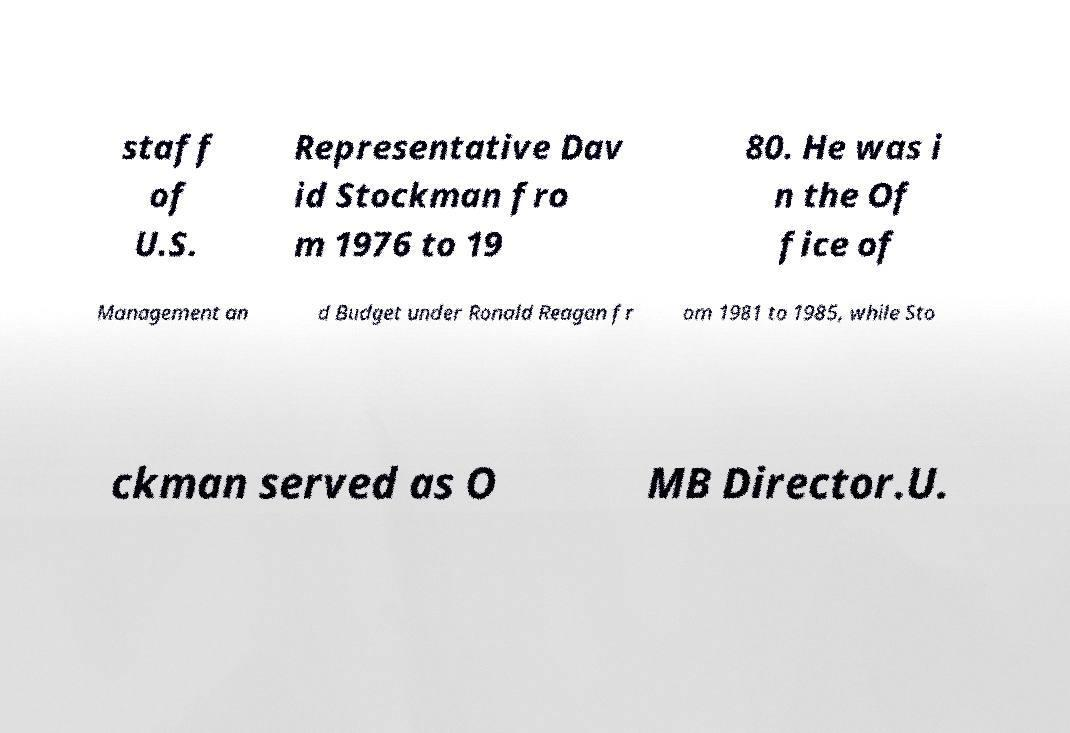Please read and relay the text visible in this image. What does it say? staff of U.S. Representative Dav id Stockman fro m 1976 to 19 80. He was i n the Of fice of Management an d Budget under Ronald Reagan fr om 1981 to 1985, while Sto ckman served as O MB Director.U. 